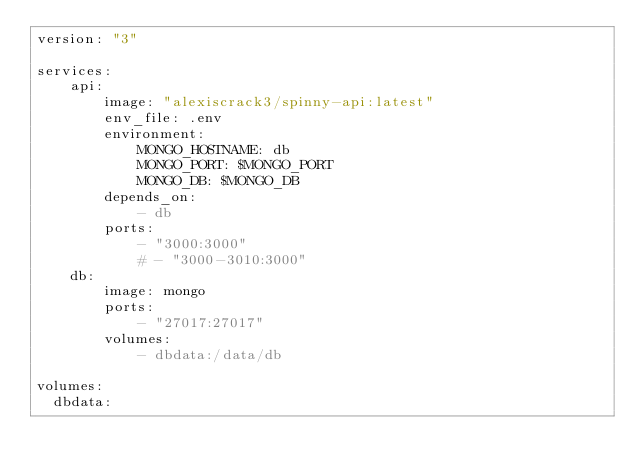<code> <loc_0><loc_0><loc_500><loc_500><_YAML_>version: "3"

services: 
    api:
        image: "alexiscrack3/spinny-api:latest"
        env_file: .env
        environment: 
            MONGO_HOSTNAME: db
            MONGO_PORT: $MONGO_PORT
            MONGO_DB: $MONGO_DB
        depends_on: 
            - db
        ports: 
            - "3000:3000"
            # - "3000-3010:3000"
    db:
        image: mongo
        ports:
            - "27017:27017"
        volumes:
            - dbdata:/data/db

volumes:
  dbdata:
</code> 